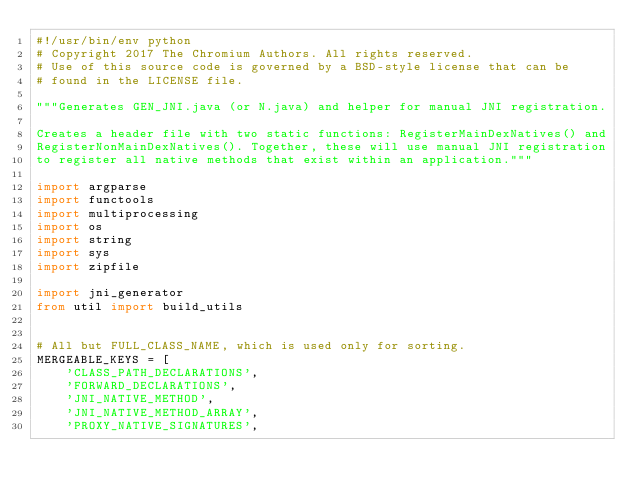Convert code to text. <code><loc_0><loc_0><loc_500><loc_500><_Python_>#!/usr/bin/env python
# Copyright 2017 The Chromium Authors. All rights reserved.
# Use of this source code is governed by a BSD-style license that can be
# found in the LICENSE file.

"""Generates GEN_JNI.java (or N.java) and helper for manual JNI registration.

Creates a header file with two static functions: RegisterMainDexNatives() and
RegisterNonMainDexNatives(). Together, these will use manual JNI registration
to register all native methods that exist within an application."""

import argparse
import functools
import multiprocessing
import os
import string
import sys
import zipfile

import jni_generator
from util import build_utils


# All but FULL_CLASS_NAME, which is used only for sorting.
MERGEABLE_KEYS = [
    'CLASS_PATH_DECLARATIONS',
    'FORWARD_DECLARATIONS',
    'JNI_NATIVE_METHOD',
    'JNI_NATIVE_METHOD_ARRAY',
    'PROXY_NATIVE_SIGNATURES',</code> 